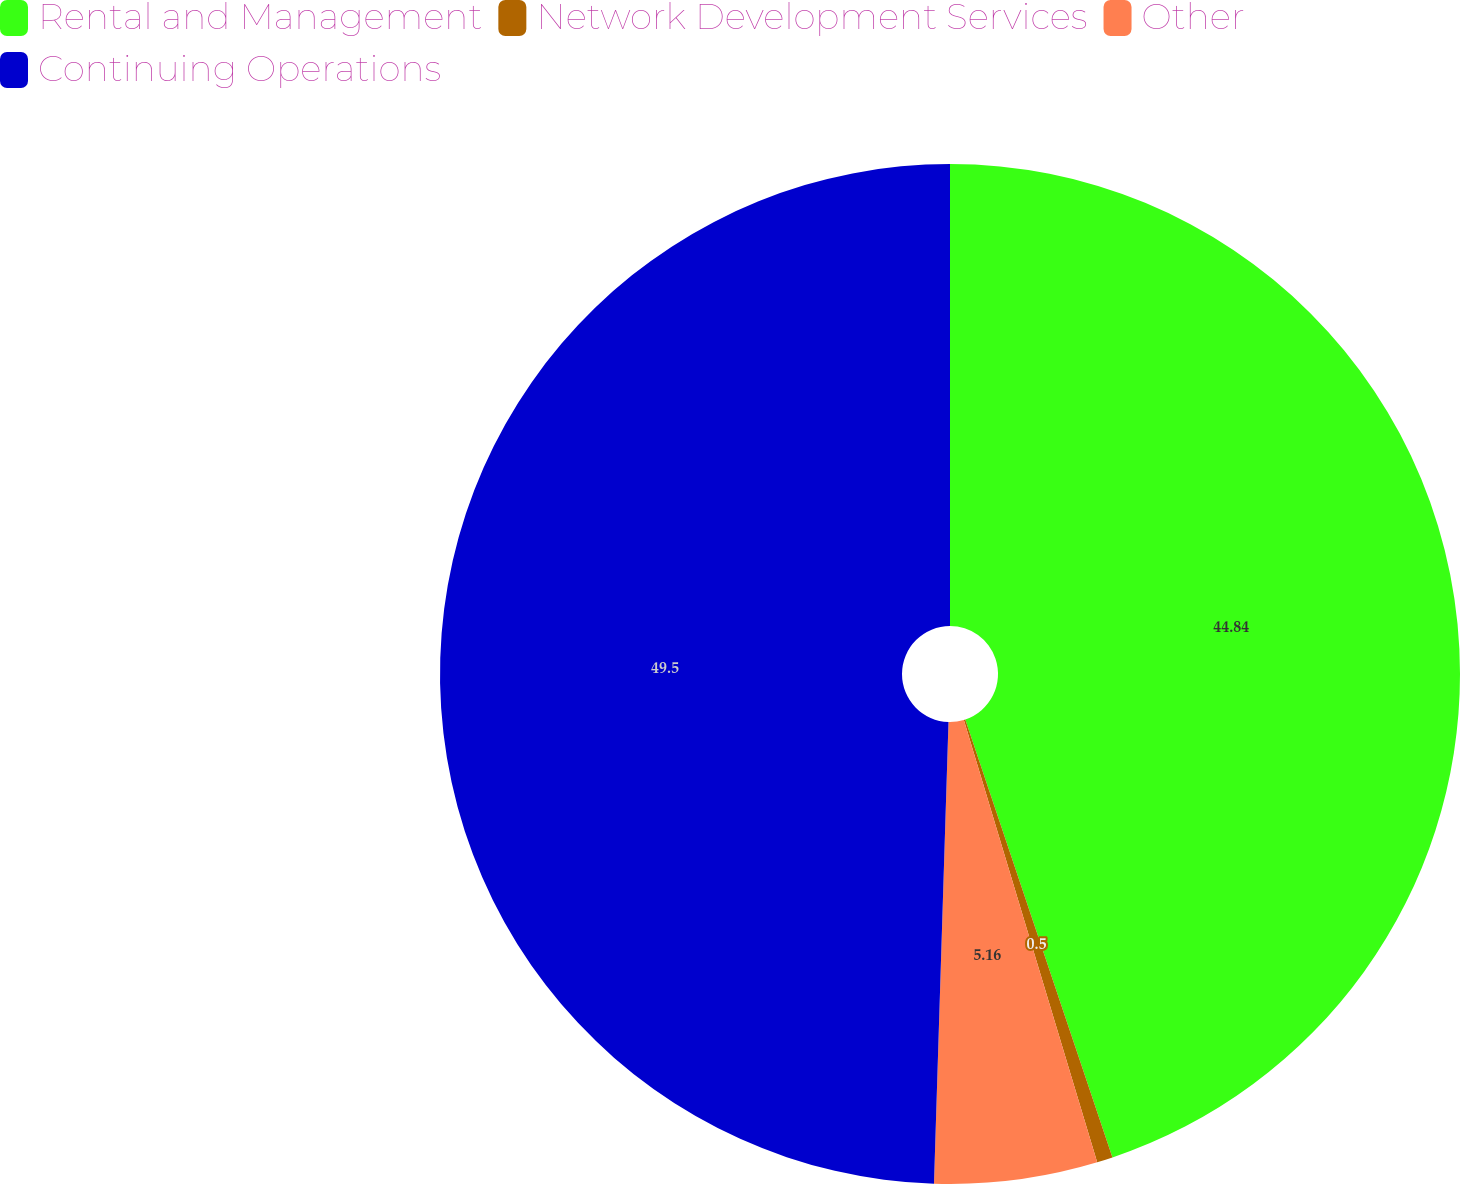Convert chart. <chart><loc_0><loc_0><loc_500><loc_500><pie_chart><fcel>Rental and Management<fcel>Network Development Services<fcel>Other<fcel>Continuing Operations<nl><fcel>44.84%<fcel>0.5%<fcel>5.16%<fcel>49.5%<nl></chart> 